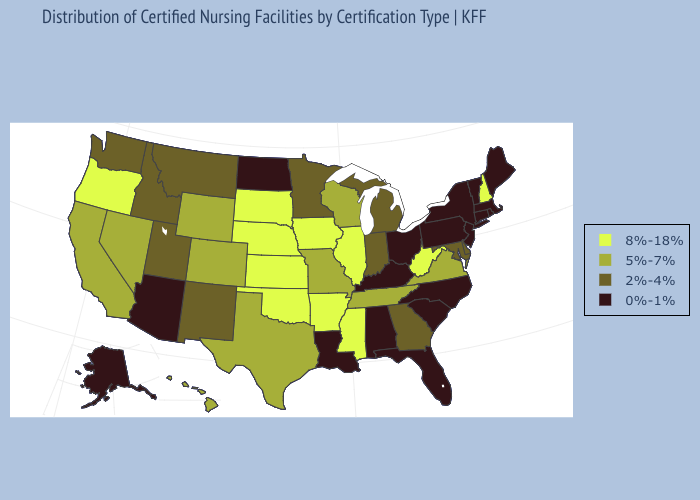Among the states that border Iowa , which have the highest value?
Quick response, please. Illinois, Nebraska, South Dakota. Name the states that have a value in the range 5%-7%?
Short answer required. California, Colorado, Hawaii, Missouri, Nevada, Tennessee, Texas, Virginia, Wisconsin, Wyoming. Name the states that have a value in the range 8%-18%?
Concise answer only. Arkansas, Illinois, Iowa, Kansas, Mississippi, Nebraska, New Hampshire, Oklahoma, Oregon, South Dakota, West Virginia. What is the highest value in states that border Washington?
Quick response, please. 8%-18%. What is the highest value in states that border Delaware?
Keep it brief. 2%-4%. Name the states that have a value in the range 2%-4%?
Write a very short answer. Delaware, Georgia, Idaho, Indiana, Maryland, Michigan, Minnesota, Montana, New Mexico, Utah, Washington. How many symbols are there in the legend?
Be succinct. 4. Does the map have missing data?
Answer briefly. No. What is the highest value in the MidWest ?
Be succinct. 8%-18%. Does Virginia have the lowest value in the South?
Give a very brief answer. No. Does Oklahoma have the highest value in the USA?
Answer briefly. Yes. Name the states that have a value in the range 5%-7%?
Answer briefly. California, Colorado, Hawaii, Missouri, Nevada, Tennessee, Texas, Virginia, Wisconsin, Wyoming. What is the highest value in states that border South Dakota?
Write a very short answer. 8%-18%. 